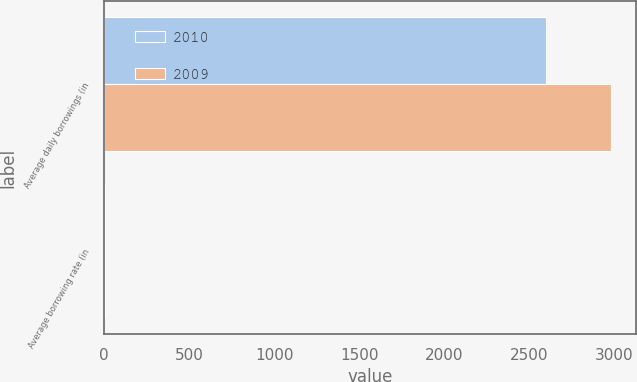Convert chart. <chart><loc_0><loc_0><loc_500><loc_500><stacked_bar_chart><ecel><fcel>Average daily borrowings (in<fcel>Average borrowing rate (in<nl><fcel>2010<fcel>2602<fcel>7<nl><fcel>2009<fcel>2982<fcel>6.7<nl></chart> 